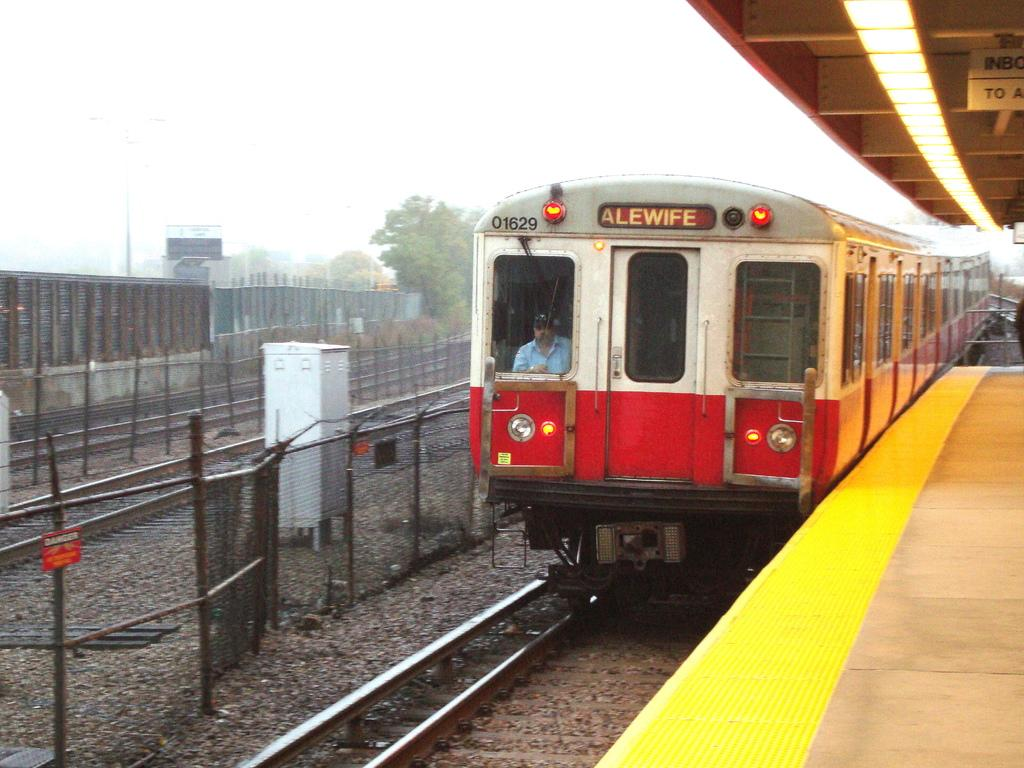Provide a one-sentence caption for the provided image. A train that is titled Alewife assumingly where it is headed. 